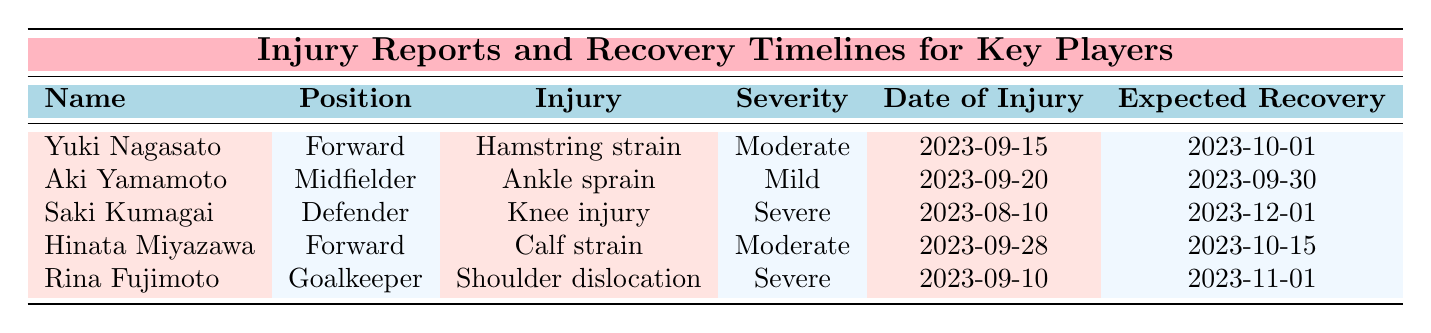What injury does Yuki Nagasato have? The table lists Yuki Nagasato's injury as a "Hamstring strain."
Answer: Hamstring strain What is the severity of Saki Kumagai's injury? The table indicates that Saki Kumagai's injury severity is classified as "Severe."
Answer: Severe How many players are expected to recover by October 1, 2023? The table shows that both Yuki Nagasato and Hinata Miyazawa are expected to recover by October 1, 2023, and October 15, 2023, respectively. Thus, only Yuki Nagasato qualifies.
Answer: 1 Which player suffered a shoulder dislocation? The table shows that Rina Fujimoto suffered a "Shoulder dislocation."
Answer: Rina Fujimoto Is Aki Yamamoto's injury classified as severe? The table specifies that Aki Yamamoto's injury severity is classified as "Mild," therefore the statement is false.
Answer: No What is the time between Saki Kumagai's injury date and her expected recovery date? Saki Kumagai's injury occurred on August 10, 2023, and she is expected to recover by December 1, 2023. The time between these dates is 113 days.
Answer: 113 days Which player will be unavailable for the longest period? The table shows that Saki Kumagai's injury is classified as severe and has the longest expected recovery date, which is December 1, 2023.
Answer: Saki Kumagai How many players injured in September have an expected recovery date before November? The table indicates that Aki Yamamoto and Yuki Nagasato, both injured in September, have expected recovery dates of September 30 and October 1, respectively, while Rina Fujimoto will recover by November 1. Therefore, only Aki and Yuki meet this criterion.
Answer: 2 Which defender is currently injured? The table lists Saki Kumagai as a defender who is currently injured.
Answer: Saki Kumagai What is the earliest date of injury among the listed players? The table shows that Saki Kumagai's injury date is August 10, 2023, which is the earliest among all players.
Answer: August 10, 2023 How many players are forwards, and what are their injuries? The table indicates there are two forwards: Yuki Nagasato with a hamstring strain and Hinata Miyazawa with a calf strain.
Answer: 2 forwards: Hamstring strain, Calf strain 